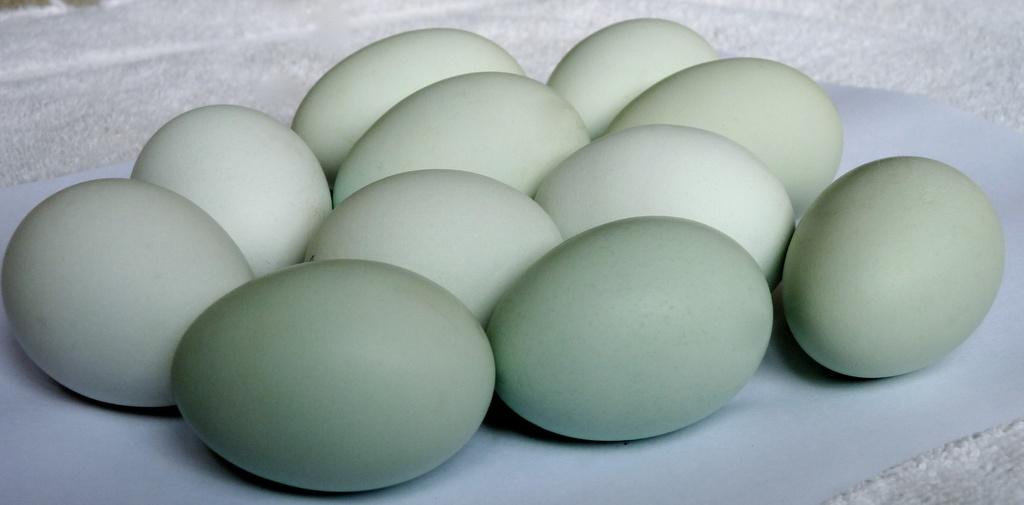What is present in the image? There are eggs in the image. How are the eggs arranged or placed? The eggs are kept on white paper. Are there any plants visible in the image? There are no plants visible in the image. Can you see any steam coming from the eggs in the image? There is no steam present in the image. 